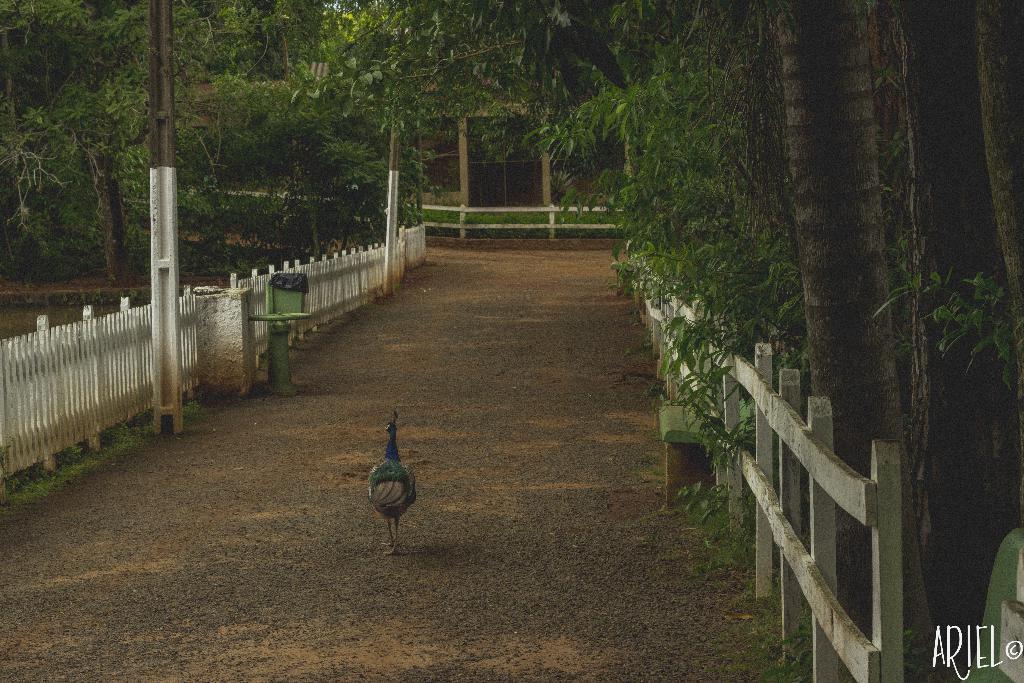How would you summarize this image in a sentence or two? In this image I can see a peacock on the ground. On the right and left side of the image I can see the railings and many trees. On the left side there are two poles. In the background there are some plants and pillars. 